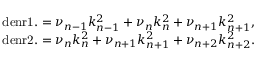<formula> <loc_0><loc_0><loc_500><loc_500>\begin{array} { r } { d e n r 1 . = \nu _ { n - 1 } k _ { n - 1 } ^ { 2 } + \nu _ { n } k _ { n } ^ { 2 } + \nu _ { n + 1 } k _ { n + 1 } ^ { 2 } , } \\ { d e n r 2 . = \nu _ { n } k _ { n } ^ { 2 } + \nu _ { n + 1 } k _ { n + 1 } ^ { 2 } + \nu _ { n + 2 } k _ { n + 2 } ^ { 2 } . } \end{array}</formula> 